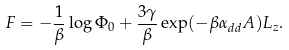<formula> <loc_0><loc_0><loc_500><loc_500>F = - \frac { 1 } { \beta } \log \Phi _ { 0 } + \frac { 3 \gamma } { \beta } \exp ( - \beta \alpha _ { d d } A ) L _ { z } .</formula> 